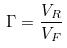<formula> <loc_0><loc_0><loc_500><loc_500>\Gamma = \frac { V _ { R } } { V _ { F } }</formula> 